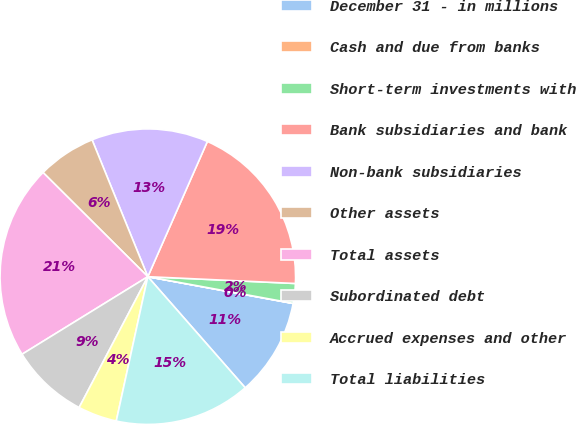Convert chart to OTSL. <chart><loc_0><loc_0><loc_500><loc_500><pie_chart><fcel>December 31 - in millions<fcel>Cash and due from banks<fcel>Short-term investments with<fcel>Bank subsidiaries and bank<fcel>Non-bank subsidiaries<fcel>Other assets<fcel>Total assets<fcel>Subordinated debt<fcel>Accrued expenses and other<fcel>Total liabilities<nl><fcel>10.64%<fcel>0.02%<fcel>2.15%<fcel>19.13%<fcel>12.76%<fcel>6.39%<fcel>21.25%<fcel>8.51%<fcel>4.27%<fcel>14.88%<nl></chart> 